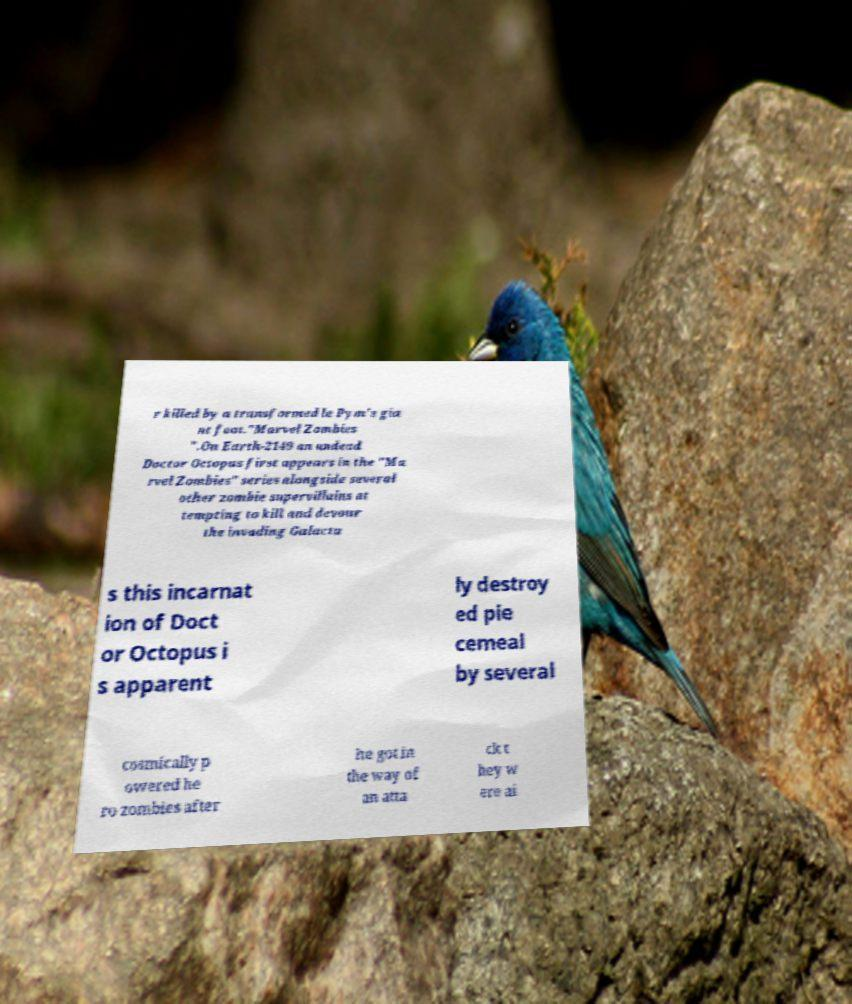For documentation purposes, I need the text within this image transcribed. Could you provide that? r killed by a transformed le Pym's gia nt foot."Marvel Zombies ".On Earth-2149 an undead Doctor Octopus first appears in the "Ma rvel Zombies" series alongside several other zombie supervillains at tempting to kill and devour the invading Galactu s this incarnat ion of Doct or Octopus i s apparent ly destroy ed pie cemeal by several cosmically p owered he ro zombies after he got in the way of an atta ck t hey w ere ai 